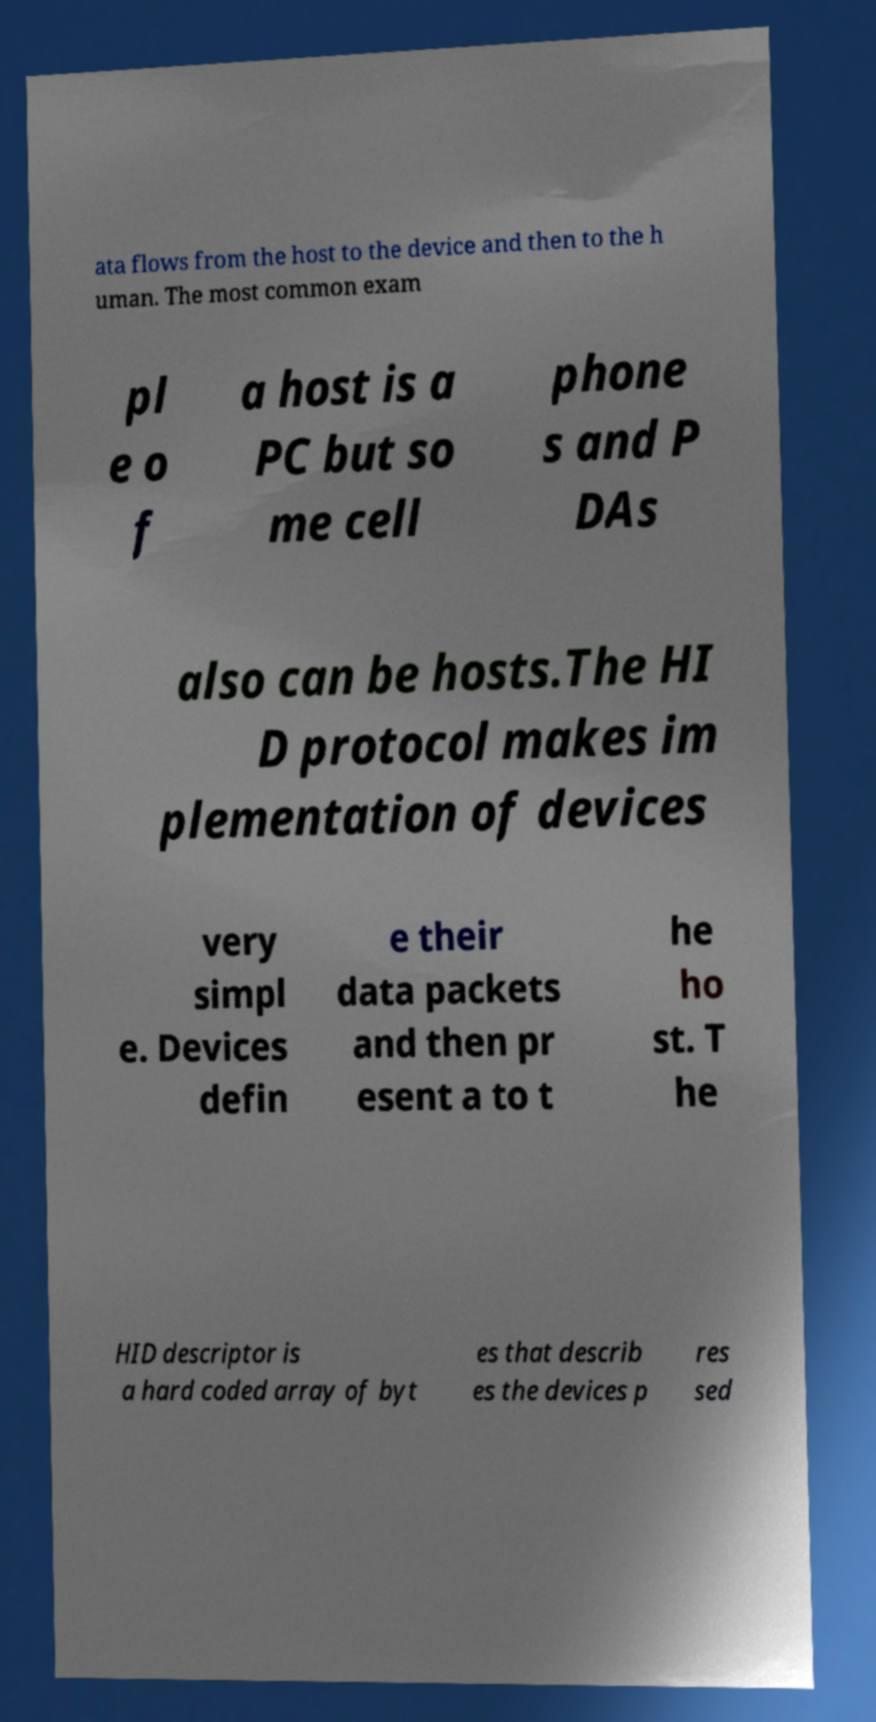There's text embedded in this image that I need extracted. Can you transcribe it verbatim? ata flows from the host to the device and then to the h uman. The most common exam pl e o f a host is a PC but so me cell phone s and P DAs also can be hosts.The HI D protocol makes im plementation of devices very simpl e. Devices defin e their data packets and then pr esent a to t he ho st. T he HID descriptor is a hard coded array of byt es that describ es the devices p res sed 